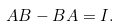Convert formula to latex. <formula><loc_0><loc_0><loc_500><loc_500>A B - B A = I .</formula> 